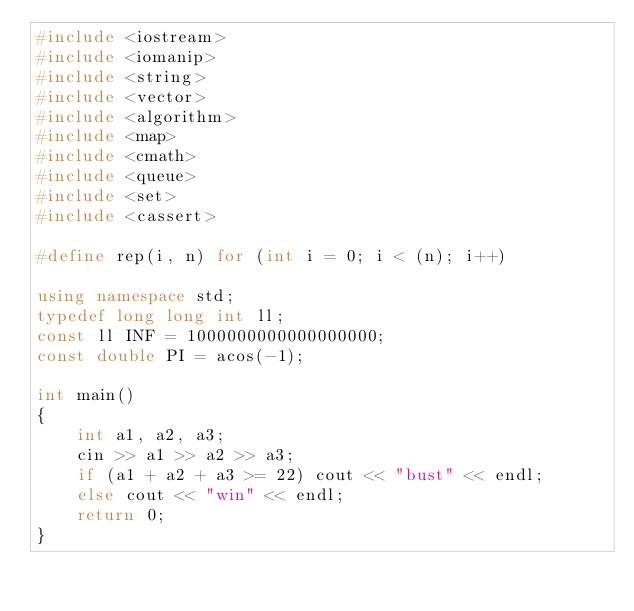Convert code to text. <code><loc_0><loc_0><loc_500><loc_500><_C++_>#include <iostream>
#include <iomanip>
#include <string>
#include <vector>
#include <algorithm>
#include <map>
#include <cmath>
#include <queue>
#include <set>
#include <cassert>

#define rep(i, n) for (int i = 0; i < (n); i++)

using namespace std;
typedef long long int ll;
const ll INF = 1000000000000000000;
const double PI = acos(-1);

int main()
{
    int a1, a2, a3;
    cin >> a1 >> a2 >> a3;
    if (a1 + a2 + a3 >= 22) cout << "bust" << endl;
    else cout << "win" << endl;
    return 0;
}</code> 